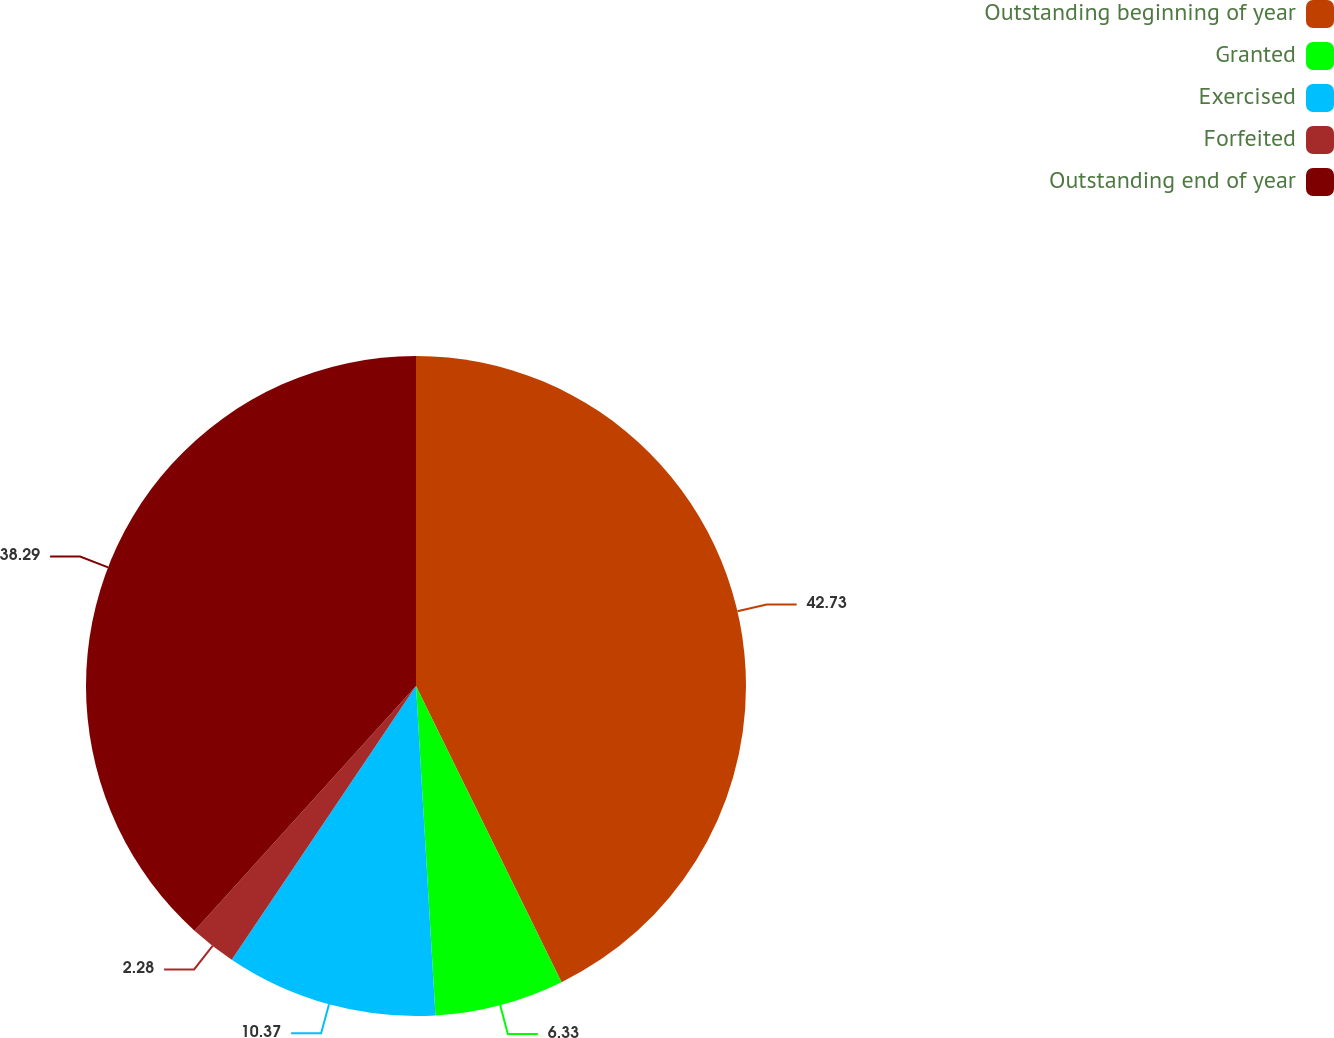Convert chart. <chart><loc_0><loc_0><loc_500><loc_500><pie_chart><fcel>Outstanding beginning of year<fcel>Granted<fcel>Exercised<fcel>Forfeited<fcel>Outstanding end of year<nl><fcel>42.73%<fcel>6.33%<fcel>10.37%<fcel>2.28%<fcel>38.29%<nl></chart> 